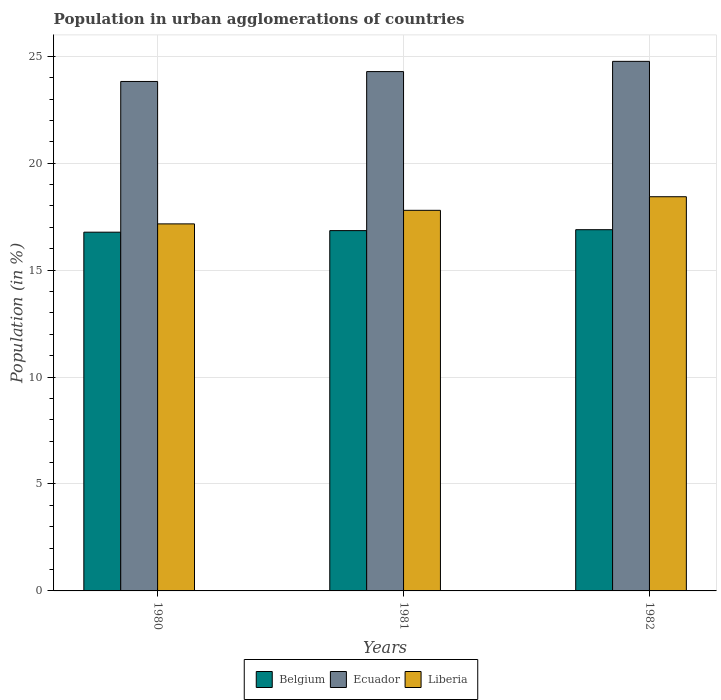Are the number of bars per tick equal to the number of legend labels?
Offer a terse response. Yes. How many bars are there on the 1st tick from the left?
Make the answer very short. 3. What is the label of the 3rd group of bars from the left?
Provide a short and direct response. 1982. In how many cases, is the number of bars for a given year not equal to the number of legend labels?
Make the answer very short. 0. What is the percentage of population in urban agglomerations in Ecuador in 1981?
Make the answer very short. 24.28. Across all years, what is the maximum percentage of population in urban agglomerations in Ecuador?
Your answer should be very brief. 24.76. Across all years, what is the minimum percentage of population in urban agglomerations in Belgium?
Offer a very short reply. 16.77. In which year was the percentage of population in urban agglomerations in Liberia maximum?
Offer a very short reply. 1982. What is the total percentage of population in urban agglomerations in Liberia in the graph?
Offer a very short reply. 53.39. What is the difference between the percentage of population in urban agglomerations in Ecuador in 1981 and that in 1982?
Your answer should be very brief. -0.48. What is the difference between the percentage of population in urban agglomerations in Liberia in 1981 and the percentage of population in urban agglomerations in Ecuador in 1982?
Keep it short and to the point. -6.97. What is the average percentage of population in urban agglomerations in Belgium per year?
Offer a very short reply. 16.84. In the year 1980, what is the difference between the percentage of population in urban agglomerations in Belgium and percentage of population in urban agglomerations in Ecuador?
Provide a short and direct response. -7.05. What is the ratio of the percentage of population in urban agglomerations in Liberia in 1980 to that in 1981?
Offer a very short reply. 0.96. Is the percentage of population in urban agglomerations in Liberia in 1981 less than that in 1982?
Ensure brevity in your answer.  Yes. What is the difference between the highest and the second highest percentage of population in urban agglomerations in Ecuador?
Keep it short and to the point. 0.48. What is the difference between the highest and the lowest percentage of population in urban agglomerations in Ecuador?
Offer a terse response. 0.94. In how many years, is the percentage of population in urban agglomerations in Ecuador greater than the average percentage of population in urban agglomerations in Ecuador taken over all years?
Ensure brevity in your answer.  1. Is the sum of the percentage of population in urban agglomerations in Ecuador in 1980 and 1982 greater than the maximum percentage of population in urban agglomerations in Liberia across all years?
Your answer should be compact. Yes. What does the 2nd bar from the right in 1980 represents?
Your answer should be very brief. Ecuador. How many bars are there?
Offer a very short reply. 9. What is the difference between two consecutive major ticks on the Y-axis?
Give a very brief answer. 5. Does the graph contain any zero values?
Offer a very short reply. No. Does the graph contain grids?
Give a very brief answer. Yes. How many legend labels are there?
Your answer should be compact. 3. What is the title of the graph?
Your response must be concise. Population in urban agglomerations of countries. Does "South Africa" appear as one of the legend labels in the graph?
Give a very brief answer. No. What is the Population (in %) in Belgium in 1980?
Offer a terse response. 16.77. What is the Population (in %) in Ecuador in 1980?
Your response must be concise. 23.82. What is the Population (in %) in Liberia in 1980?
Keep it short and to the point. 17.16. What is the Population (in %) in Belgium in 1981?
Provide a short and direct response. 16.85. What is the Population (in %) of Ecuador in 1981?
Give a very brief answer. 24.28. What is the Population (in %) of Liberia in 1981?
Offer a very short reply. 17.8. What is the Population (in %) in Belgium in 1982?
Offer a very short reply. 16.89. What is the Population (in %) in Ecuador in 1982?
Provide a short and direct response. 24.76. What is the Population (in %) of Liberia in 1982?
Make the answer very short. 18.43. Across all years, what is the maximum Population (in %) in Belgium?
Ensure brevity in your answer.  16.89. Across all years, what is the maximum Population (in %) in Ecuador?
Offer a very short reply. 24.76. Across all years, what is the maximum Population (in %) in Liberia?
Provide a short and direct response. 18.43. Across all years, what is the minimum Population (in %) of Belgium?
Provide a short and direct response. 16.77. Across all years, what is the minimum Population (in %) of Ecuador?
Give a very brief answer. 23.82. Across all years, what is the minimum Population (in %) of Liberia?
Make the answer very short. 17.16. What is the total Population (in %) in Belgium in the graph?
Your answer should be very brief. 50.51. What is the total Population (in %) of Ecuador in the graph?
Your answer should be very brief. 72.87. What is the total Population (in %) of Liberia in the graph?
Provide a short and direct response. 53.39. What is the difference between the Population (in %) of Belgium in 1980 and that in 1981?
Make the answer very short. -0.07. What is the difference between the Population (in %) of Ecuador in 1980 and that in 1981?
Keep it short and to the point. -0.46. What is the difference between the Population (in %) of Liberia in 1980 and that in 1981?
Your answer should be compact. -0.63. What is the difference between the Population (in %) of Belgium in 1980 and that in 1982?
Your answer should be compact. -0.12. What is the difference between the Population (in %) of Ecuador in 1980 and that in 1982?
Provide a succinct answer. -0.94. What is the difference between the Population (in %) in Liberia in 1980 and that in 1982?
Give a very brief answer. -1.27. What is the difference between the Population (in %) of Belgium in 1981 and that in 1982?
Provide a short and direct response. -0.04. What is the difference between the Population (in %) in Ecuador in 1981 and that in 1982?
Offer a terse response. -0.48. What is the difference between the Population (in %) in Liberia in 1981 and that in 1982?
Provide a succinct answer. -0.64. What is the difference between the Population (in %) in Belgium in 1980 and the Population (in %) in Ecuador in 1981?
Offer a very short reply. -7.51. What is the difference between the Population (in %) in Belgium in 1980 and the Population (in %) in Liberia in 1981?
Provide a short and direct response. -1.02. What is the difference between the Population (in %) in Ecuador in 1980 and the Population (in %) in Liberia in 1981?
Offer a very short reply. 6.03. What is the difference between the Population (in %) in Belgium in 1980 and the Population (in %) in Ecuador in 1982?
Offer a very short reply. -7.99. What is the difference between the Population (in %) of Belgium in 1980 and the Population (in %) of Liberia in 1982?
Your answer should be compact. -1.66. What is the difference between the Population (in %) in Ecuador in 1980 and the Population (in %) in Liberia in 1982?
Your answer should be very brief. 5.39. What is the difference between the Population (in %) of Belgium in 1981 and the Population (in %) of Ecuador in 1982?
Your answer should be very brief. -7.91. What is the difference between the Population (in %) of Belgium in 1981 and the Population (in %) of Liberia in 1982?
Offer a very short reply. -1.58. What is the difference between the Population (in %) in Ecuador in 1981 and the Population (in %) in Liberia in 1982?
Give a very brief answer. 5.85. What is the average Population (in %) in Belgium per year?
Your answer should be very brief. 16.84. What is the average Population (in %) in Ecuador per year?
Keep it short and to the point. 24.29. What is the average Population (in %) in Liberia per year?
Make the answer very short. 17.8. In the year 1980, what is the difference between the Population (in %) of Belgium and Population (in %) of Ecuador?
Provide a short and direct response. -7.05. In the year 1980, what is the difference between the Population (in %) of Belgium and Population (in %) of Liberia?
Your answer should be compact. -0.39. In the year 1980, what is the difference between the Population (in %) in Ecuador and Population (in %) in Liberia?
Your answer should be compact. 6.66. In the year 1981, what is the difference between the Population (in %) of Belgium and Population (in %) of Ecuador?
Your response must be concise. -7.44. In the year 1981, what is the difference between the Population (in %) in Belgium and Population (in %) in Liberia?
Keep it short and to the point. -0.95. In the year 1981, what is the difference between the Population (in %) of Ecuador and Population (in %) of Liberia?
Keep it short and to the point. 6.49. In the year 1982, what is the difference between the Population (in %) in Belgium and Population (in %) in Ecuador?
Offer a very short reply. -7.87. In the year 1982, what is the difference between the Population (in %) in Belgium and Population (in %) in Liberia?
Give a very brief answer. -1.54. In the year 1982, what is the difference between the Population (in %) of Ecuador and Population (in %) of Liberia?
Make the answer very short. 6.33. What is the ratio of the Population (in %) in Ecuador in 1980 to that in 1981?
Your answer should be compact. 0.98. What is the ratio of the Population (in %) in Ecuador in 1980 to that in 1982?
Provide a short and direct response. 0.96. What is the ratio of the Population (in %) of Liberia in 1980 to that in 1982?
Your response must be concise. 0.93. What is the ratio of the Population (in %) in Belgium in 1981 to that in 1982?
Your response must be concise. 1. What is the ratio of the Population (in %) of Ecuador in 1981 to that in 1982?
Your answer should be compact. 0.98. What is the ratio of the Population (in %) in Liberia in 1981 to that in 1982?
Ensure brevity in your answer.  0.97. What is the difference between the highest and the second highest Population (in %) in Belgium?
Provide a succinct answer. 0.04. What is the difference between the highest and the second highest Population (in %) in Ecuador?
Give a very brief answer. 0.48. What is the difference between the highest and the second highest Population (in %) of Liberia?
Provide a short and direct response. 0.64. What is the difference between the highest and the lowest Population (in %) in Belgium?
Your answer should be compact. 0.12. What is the difference between the highest and the lowest Population (in %) of Ecuador?
Keep it short and to the point. 0.94. What is the difference between the highest and the lowest Population (in %) in Liberia?
Your answer should be compact. 1.27. 